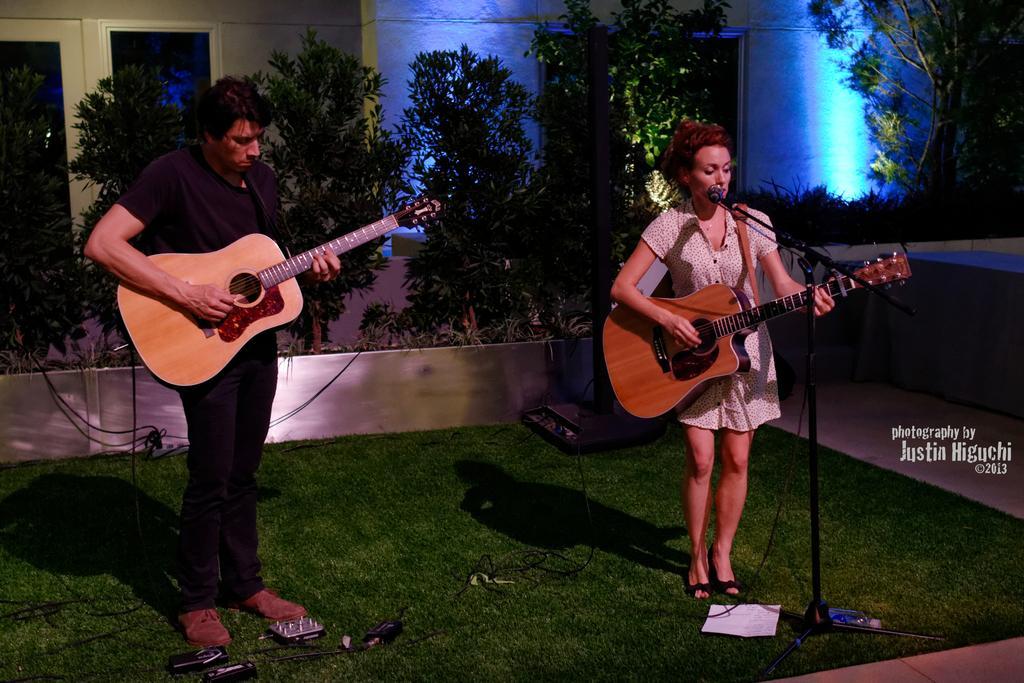Can you describe this image briefly? in the picture there are a man and woman holding a guitar, a woman singing a song in the micro phone which is in front of her there are trees present near them. 